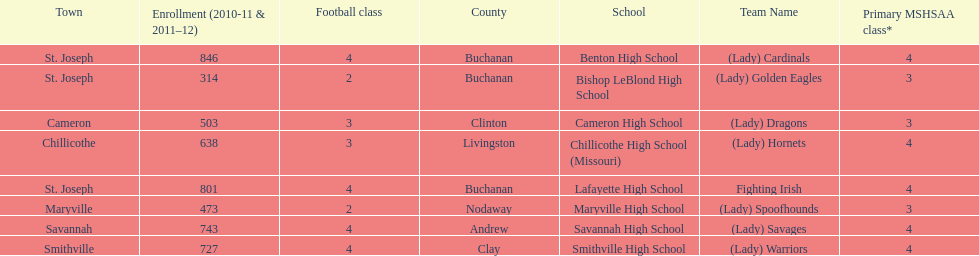Benton high school and bishop leblond high school are both located in what town? St. Joseph. 